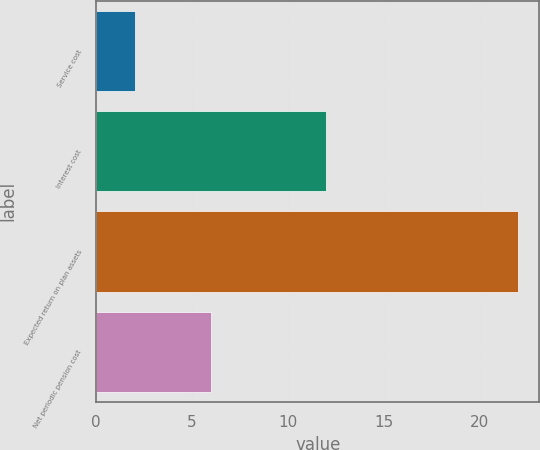<chart> <loc_0><loc_0><loc_500><loc_500><bar_chart><fcel>Service cost<fcel>Interest cost<fcel>Expected return on plan assets<fcel>Net periodic pension cost<nl><fcel>2<fcel>12<fcel>22<fcel>6<nl></chart> 